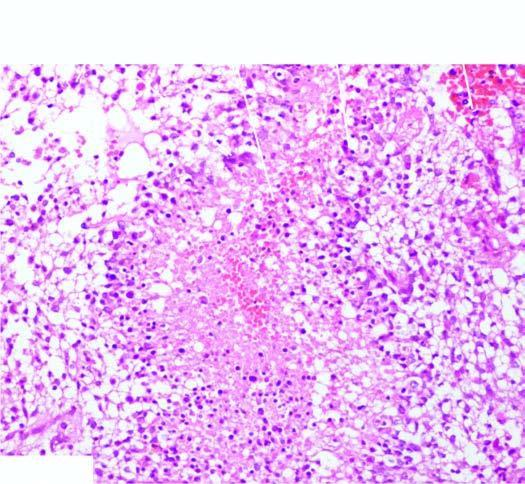what has areas of necrosis which are surrounded by a palisade layer of tumour cells?
Answer the question using a single word or phrase. Tumour 